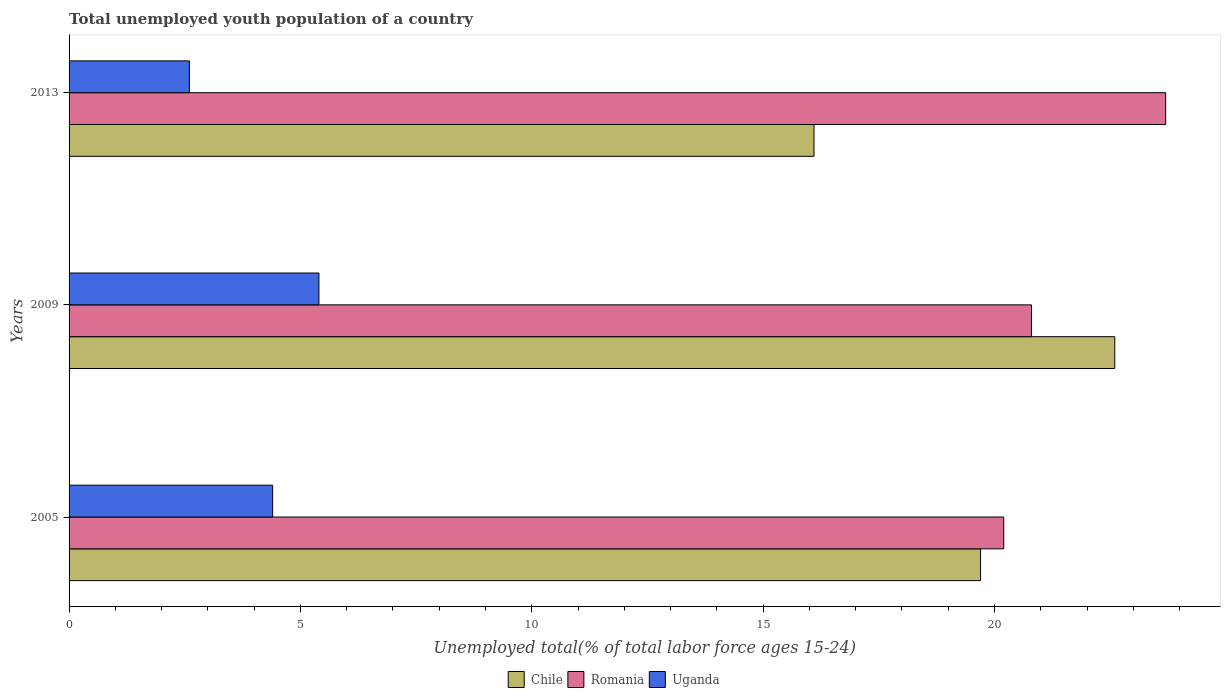How many different coloured bars are there?
Provide a short and direct response. 3. How many groups of bars are there?
Keep it short and to the point. 3. Are the number of bars per tick equal to the number of legend labels?
Provide a succinct answer. Yes. Are the number of bars on each tick of the Y-axis equal?
Your answer should be very brief. Yes. What is the label of the 2nd group of bars from the top?
Your answer should be very brief. 2009. In how many cases, is the number of bars for a given year not equal to the number of legend labels?
Offer a terse response. 0. What is the percentage of total unemployed youth population of a country in Romania in 2005?
Your answer should be very brief. 20.2. Across all years, what is the maximum percentage of total unemployed youth population of a country in Chile?
Your response must be concise. 22.6. Across all years, what is the minimum percentage of total unemployed youth population of a country in Uganda?
Give a very brief answer. 2.6. What is the total percentage of total unemployed youth population of a country in Romania in the graph?
Ensure brevity in your answer.  64.7. What is the difference between the percentage of total unemployed youth population of a country in Uganda in 2005 and that in 2013?
Give a very brief answer. 1.8. What is the difference between the percentage of total unemployed youth population of a country in Romania in 2005 and the percentage of total unemployed youth population of a country in Uganda in 2009?
Your answer should be very brief. 14.8. What is the average percentage of total unemployed youth population of a country in Uganda per year?
Make the answer very short. 4.13. In the year 2005, what is the difference between the percentage of total unemployed youth population of a country in Romania and percentage of total unemployed youth population of a country in Uganda?
Your answer should be compact. 15.8. In how many years, is the percentage of total unemployed youth population of a country in Chile greater than 23 %?
Provide a short and direct response. 0. What is the ratio of the percentage of total unemployed youth population of a country in Romania in 2005 to that in 2009?
Your response must be concise. 0.97. Is the percentage of total unemployed youth population of a country in Chile in 2005 less than that in 2013?
Offer a very short reply. No. What is the difference between the highest and the second highest percentage of total unemployed youth population of a country in Uganda?
Your answer should be very brief. 1. What is the difference between the highest and the lowest percentage of total unemployed youth population of a country in Chile?
Your answer should be very brief. 6.5. In how many years, is the percentage of total unemployed youth population of a country in Uganda greater than the average percentage of total unemployed youth population of a country in Uganda taken over all years?
Ensure brevity in your answer.  2. What does the 1st bar from the top in 2013 represents?
Your answer should be very brief. Uganda. What does the 2nd bar from the bottom in 2005 represents?
Provide a succinct answer. Romania. How many bars are there?
Give a very brief answer. 9. Are all the bars in the graph horizontal?
Provide a succinct answer. Yes. What is the difference between two consecutive major ticks on the X-axis?
Provide a succinct answer. 5. Does the graph contain any zero values?
Provide a succinct answer. No. What is the title of the graph?
Make the answer very short. Total unemployed youth population of a country. Does "St. Martin (French part)" appear as one of the legend labels in the graph?
Your answer should be very brief. No. What is the label or title of the X-axis?
Keep it short and to the point. Unemployed total(% of total labor force ages 15-24). What is the label or title of the Y-axis?
Your answer should be compact. Years. What is the Unemployed total(% of total labor force ages 15-24) in Chile in 2005?
Your response must be concise. 19.7. What is the Unemployed total(% of total labor force ages 15-24) in Romania in 2005?
Provide a succinct answer. 20.2. What is the Unemployed total(% of total labor force ages 15-24) of Uganda in 2005?
Your response must be concise. 4.4. What is the Unemployed total(% of total labor force ages 15-24) in Chile in 2009?
Keep it short and to the point. 22.6. What is the Unemployed total(% of total labor force ages 15-24) in Romania in 2009?
Make the answer very short. 20.8. What is the Unemployed total(% of total labor force ages 15-24) in Uganda in 2009?
Your answer should be compact. 5.4. What is the Unemployed total(% of total labor force ages 15-24) in Chile in 2013?
Provide a succinct answer. 16.1. What is the Unemployed total(% of total labor force ages 15-24) of Romania in 2013?
Give a very brief answer. 23.7. What is the Unemployed total(% of total labor force ages 15-24) of Uganda in 2013?
Keep it short and to the point. 2.6. Across all years, what is the maximum Unemployed total(% of total labor force ages 15-24) in Chile?
Provide a succinct answer. 22.6. Across all years, what is the maximum Unemployed total(% of total labor force ages 15-24) in Romania?
Offer a very short reply. 23.7. Across all years, what is the maximum Unemployed total(% of total labor force ages 15-24) in Uganda?
Offer a terse response. 5.4. Across all years, what is the minimum Unemployed total(% of total labor force ages 15-24) of Chile?
Your response must be concise. 16.1. Across all years, what is the minimum Unemployed total(% of total labor force ages 15-24) of Romania?
Give a very brief answer. 20.2. Across all years, what is the minimum Unemployed total(% of total labor force ages 15-24) of Uganda?
Your answer should be very brief. 2.6. What is the total Unemployed total(% of total labor force ages 15-24) in Chile in the graph?
Your answer should be very brief. 58.4. What is the total Unemployed total(% of total labor force ages 15-24) of Romania in the graph?
Offer a very short reply. 64.7. What is the total Unemployed total(% of total labor force ages 15-24) of Uganda in the graph?
Your response must be concise. 12.4. What is the difference between the Unemployed total(% of total labor force ages 15-24) in Romania in 2005 and that in 2009?
Provide a succinct answer. -0.6. What is the difference between the Unemployed total(% of total labor force ages 15-24) in Uganda in 2005 and that in 2009?
Offer a very short reply. -1. What is the difference between the Unemployed total(% of total labor force ages 15-24) of Chile in 2005 and that in 2013?
Your answer should be compact. 3.6. What is the difference between the Unemployed total(% of total labor force ages 15-24) in Romania in 2005 and that in 2013?
Offer a very short reply. -3.5. What is the difference between the Unemployed total(% of total labor force ages 15-24) of Uganda in 2005 and that in 2013?
Provide a succinct answer. 1.8. What is the difference between the Unemployed total(% of total labor force ages 15-24) of Romania in 2009 and that in 2013?
Offer a terse response. -2.9. What is the difference between the Unemployed total(% of total labor force ages 15-24) of Chile in 2005 and the Unemployed total(% of total labor force ages 15-24) of Romania in 2009?
Offer a terse response. -1.1. What is the difference between the Unemployed total(% of total labor force ages 15-24) in Chile in 2005 and the Unemployed total(% of total labor force ages 15-24) in Uganda in 2009?
Your response must be concise. 14.3. What is the difference between the Unemployed total(% of total labor force ages 15-24) in Romania in 2005 and the Unemployed total(% of total labor force ages 15-24) in Uganda in 2009?
Offer a terse response. 14.8. What is the difference between the Unemployed total(% of total labor force ages 15-24) in Romania in 2005 and the Unemployed total(% of total labor force ages 15-24) in Uganda in 2013?
Your response must be concise. 17.6. What is the difference between the Unemployed total(% of total labor force ages 15-24) of Romania in 2009 and the Unemployed total(% of total labor force ages 15-24) of Uganda in 2013?
Give a very brief answer. 18.2. What is the average Unemployed total(% of total labor force ages 15-24) in Chile per year?
Keep it short and to the point. 19.47. What is the average Unemployed total(% of total labor force ages 15-24) of Romania per year?
Provide a short and direct response. 21.57. What is the average Unemployed total(% of total labor force ages 15-24) of Uganda per year?
Your response must be concise. 4.13. In the year 2005, what is the difference between the Unemployed total(% of total labor force ages 15-24) in Chile and Unemployed total(% of total labor force ages 15-24) in Romania?
Your response must be concise. -0.5. In the year 2005, what is the difference between the Unemployed total(% of total labor force ages 15-24) of Chile and Unemployed total(% of total labor force ages 15-24) of Uganda?
Provide a succinct answer. 15.3. In the year 2005, what is the difference between the Unemployed total(% of total labor force ages 15-24) in Romania and Unemployed total(% of total labor force ages 15-24) in Uganda?
Your answer should be compact. 15.8. In the year 2009, what is the difference between the Unemployed total(% of total labor force ages 15-24) of Chile and Unemployed total(% of total labor force ages 15-24) of Romania?
Give a very brief answer. 1.8. In the year 2013, what is the difference between the Unemployed total(% of total labor force ages 15-24) of Chile and Unemployed total(% of total labor force ages 15-24) of Romania?
Make the answer very short. -7.6. In the year 2013, what is the difference between the Unemployed total(% of total labor force ages 15-24) in Romania and Unemployed total(% of total labor force ages 15-24) in Uganda?
Your response must be concise. 21.1. What is the ratio of the Unemployed total(% of total labor force ages 15-24) in Chile in 2005 to that in 2009?
Your answer should be compact. 0.87. What is the ratio of the Unemployed total(% of total labor force ages 15-24) in Romania in 2005 to that in 2009?
Keep it short and to the point. 0.97. What is the ratio of the Unemployed total(% of total labor force ages 15-24) of Uganda in 2005 to that in 2009?
Your answer should be compact. 0.81. What is the ratio of the Unemployed total(% of total labor force ages 15-24) of Chile in 2005 to that in 2013?
Provide a short and direct response. 1.22. What is the ratio of the Unemployed total(% of total labor force ages 15-24) of Romania in 2005 to that in 2013?
Your response must be concise. 0.85. What is the ratio of the Unemployed total(% of total labor force ages 15-24) of Uganda in 2005 to that in 2013?
Your answer should be very brief. 1.69. What is the ratio of the Unemployed total(% of total labor force ages 15-24) in Chile in 2009 to that in 2013?
Give a very brief answer. 1.4. What is the ratio of the Unemployed total(% of total labor force ages 15-24) in Romania in 2009 to that in 2013?
Offer a terse response. 0.88. What is the ratio of the Unemployed total(% of total labor force ages 15-24) in Uganda in 2009 to that in 2013?
Make the answer very short. 2.08. What is the difference between the highest and the second highest Unemployed total(% of total labor force ages 15-24) of Chile?
Offer a very short reply. 2.9. What is the difference between the highest and the lowest Unemployed total(% of total labor force ages 15-24) in Chile?
Give a very brief answer. 6.5. What is the difference between the highest and the lowest Unemployed total(% of total labor force ages 15-24) of Romania?
Provide a short and direct response. 3.5. 